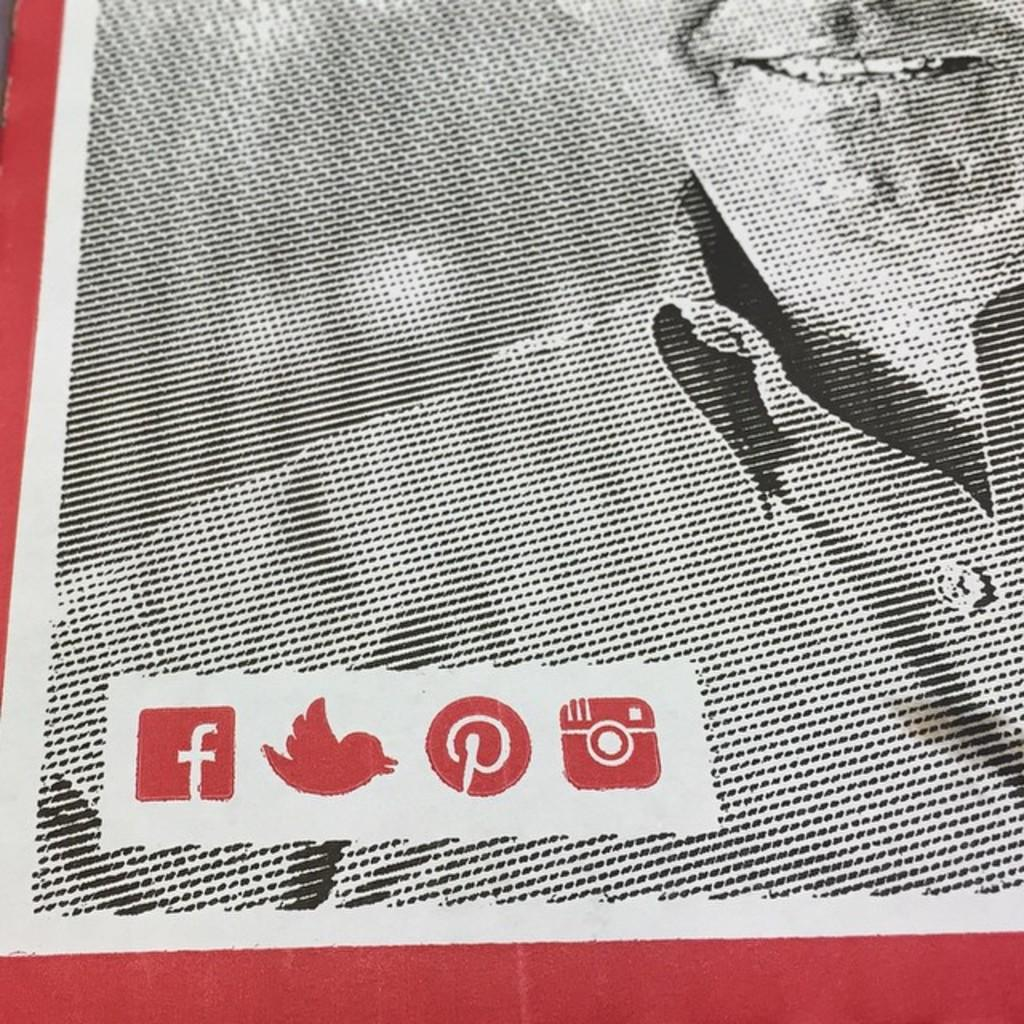What type of picture is in the image? The image contains a black and white picture of a person. What color is used for the borders of the image? The borders of the image are in red color. Where are the logos located in the image? The logos are in the left bottom corner of the image. What type of trousers is the person wearing in the image? There is no information about the person's trousers in the image, as it is a black and white picture. What angle is the image taken from? The angle from which the image is taken is not mentioned in the provided facts. 